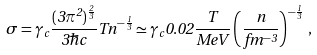<formula> <loc_0><loc_0><loc_500><loc_500>\sigma = \gamma _ { c } \frac { ( 3 \pi ^ { 2 } ) ^ { \frac { 2 } { 3 } } } { 3 \hbar { c } } T n ^ { - \frac { 1 } { 3 } } \simeq \gamma _ { c } 0 . 0 2 \frac { T } { M e V } \left ( \frac { n } { f m ^ { - 3 } } \right ) ^ { - \frac { 1 } { 3 } } \, ,</formula> 